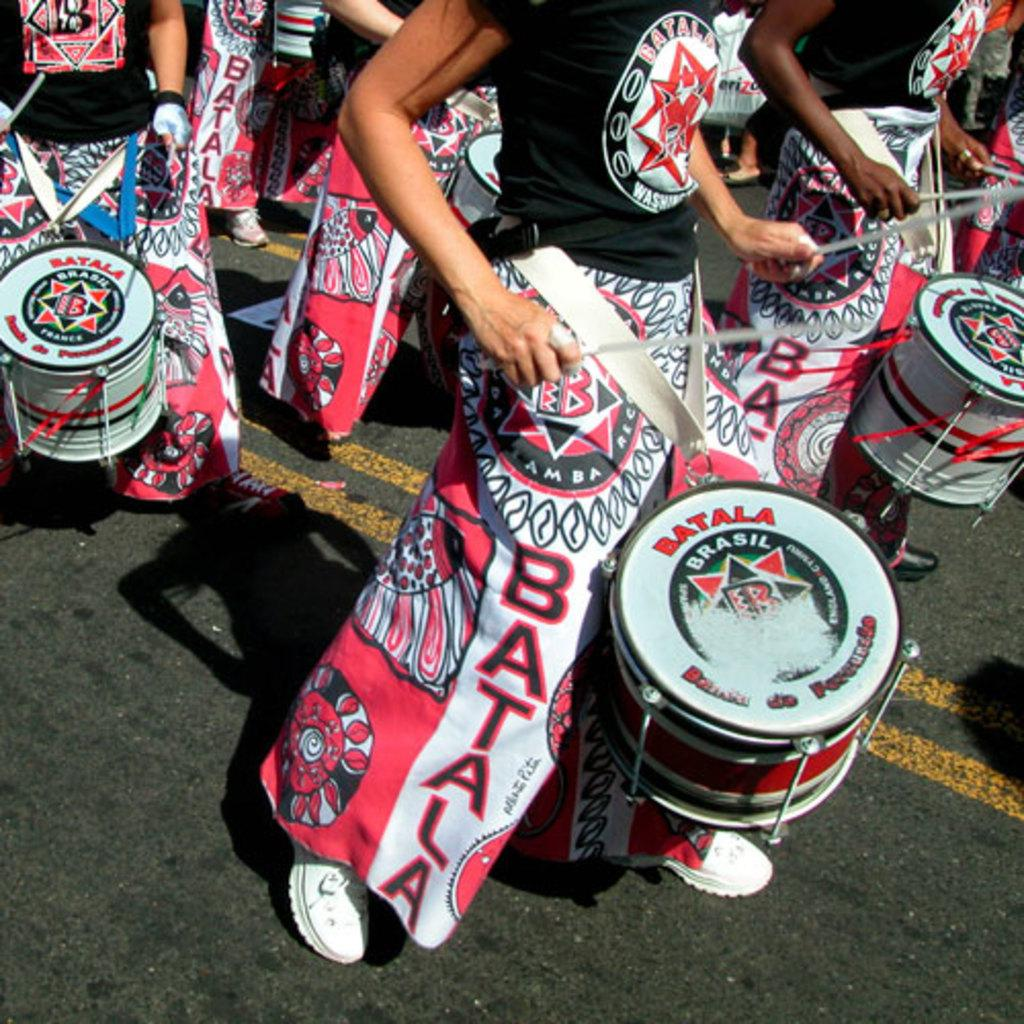<image>
Write a terse but informative summary of the picture. People wearing pink and black clothing with the word Batala on it beating Batala drums march down the street. 